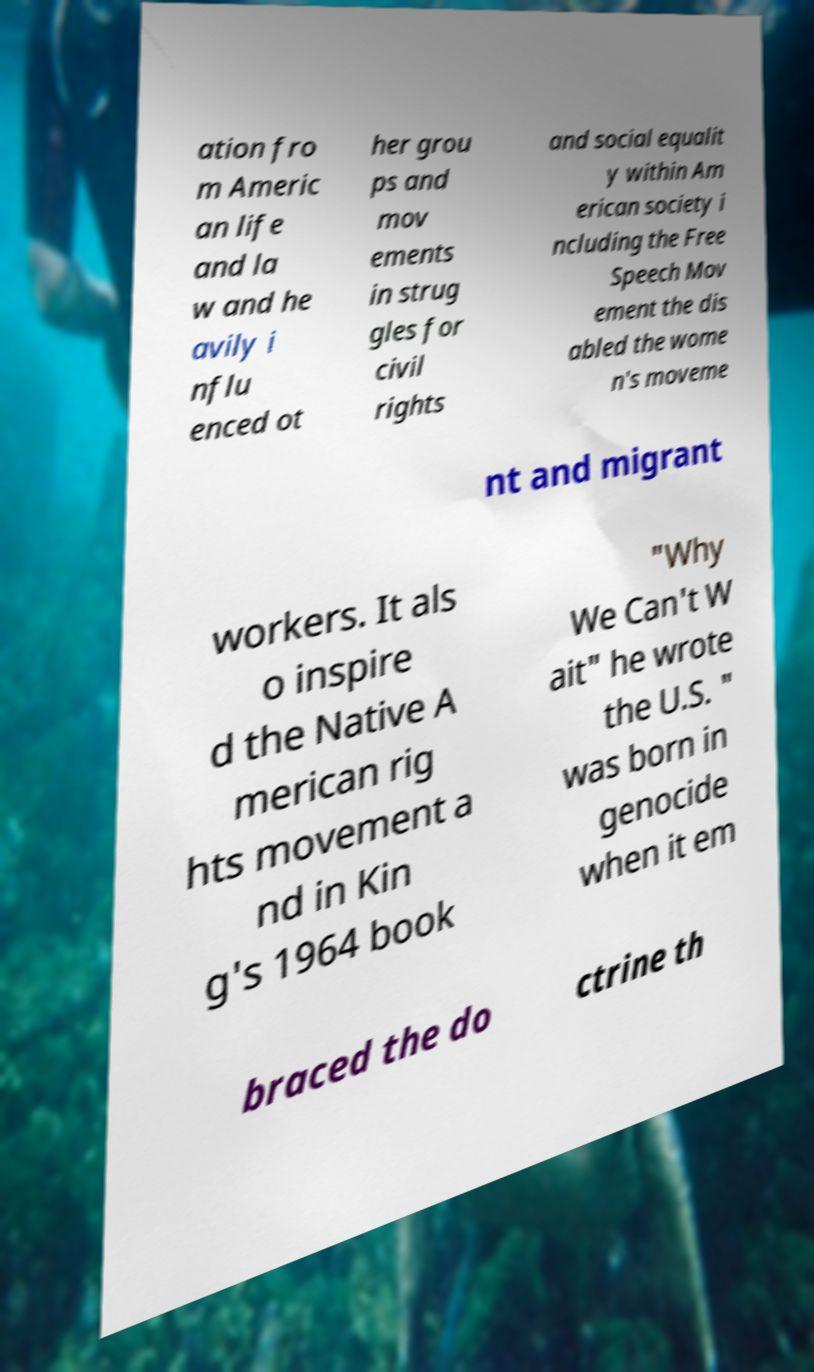I need the written content from this picture converted into text. Can you do that? ation fro m Americ an life and la w and he avily i nflu enced ot her grou ps and mov ements in strug gles for civil rights and social equalit y within Am erican society i ncluding the Free Speech Mov ement the dis abled the wome n's moveme nt and migrant workers. It als o inspire d the Native A merican rig hts movement a nd in Kin g's 1964 book "Why We Can't W ait" he wrote the U.S. " was born in genocide when it em braced the do ctrine th 